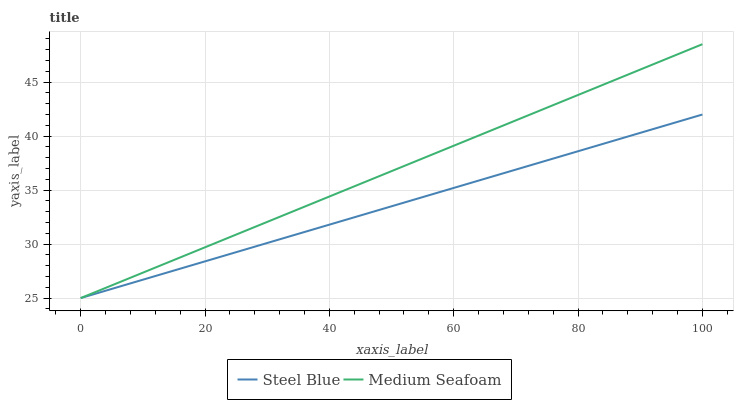Does Medium Seafoam have the minimum area under the curve?
Answer yes or no. No. Is Medium Seafoam the smoothest?
Answer yes or no. No. 